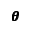<formula> <loc_0><loc_0><loc_500><loc_500>\pm b { \theta }</formula> 